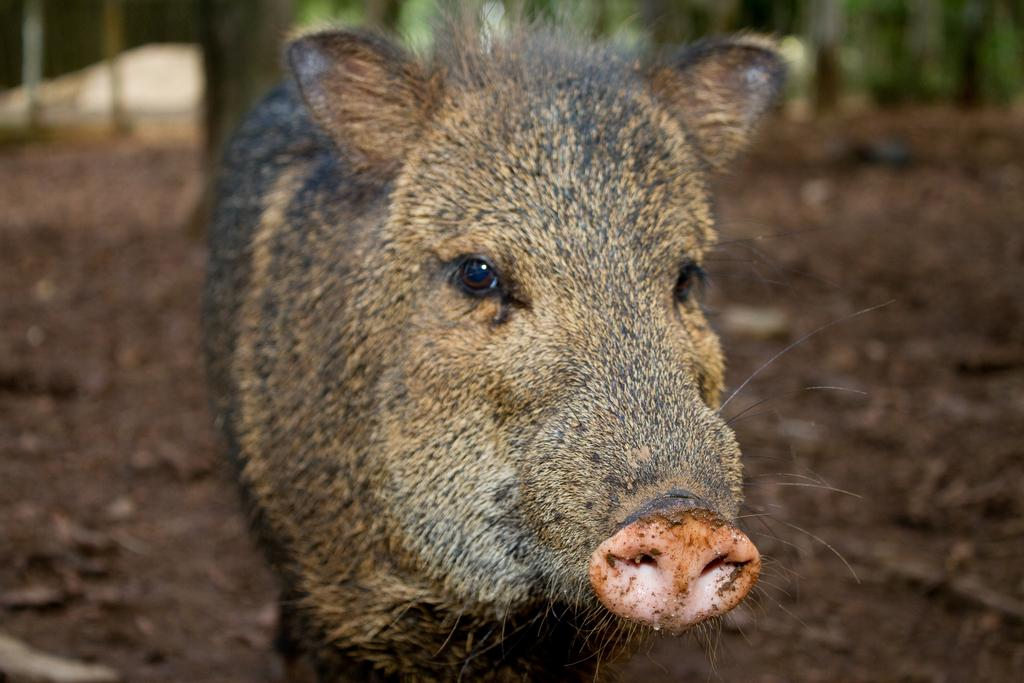What animal is present in the image? There is a pig in the image. Where is the pig located? The pig is on the ground. Can you describe the background of the image? The background of the image is blurred. What type of skirt is the pig wearing in the image? There is no skirt present in the image, as the pig is an animal and does not wear clothing. 